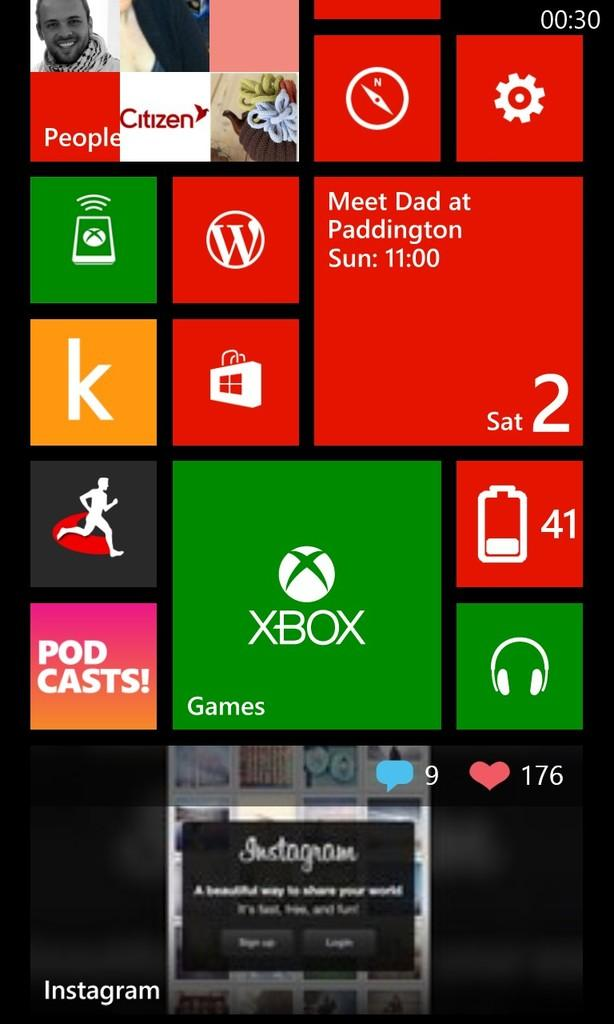<image>
Write a terse but informative summary of the picture. the screen of a windows phone featuring icons from xbox and a reminder to meet dad at paddington. 